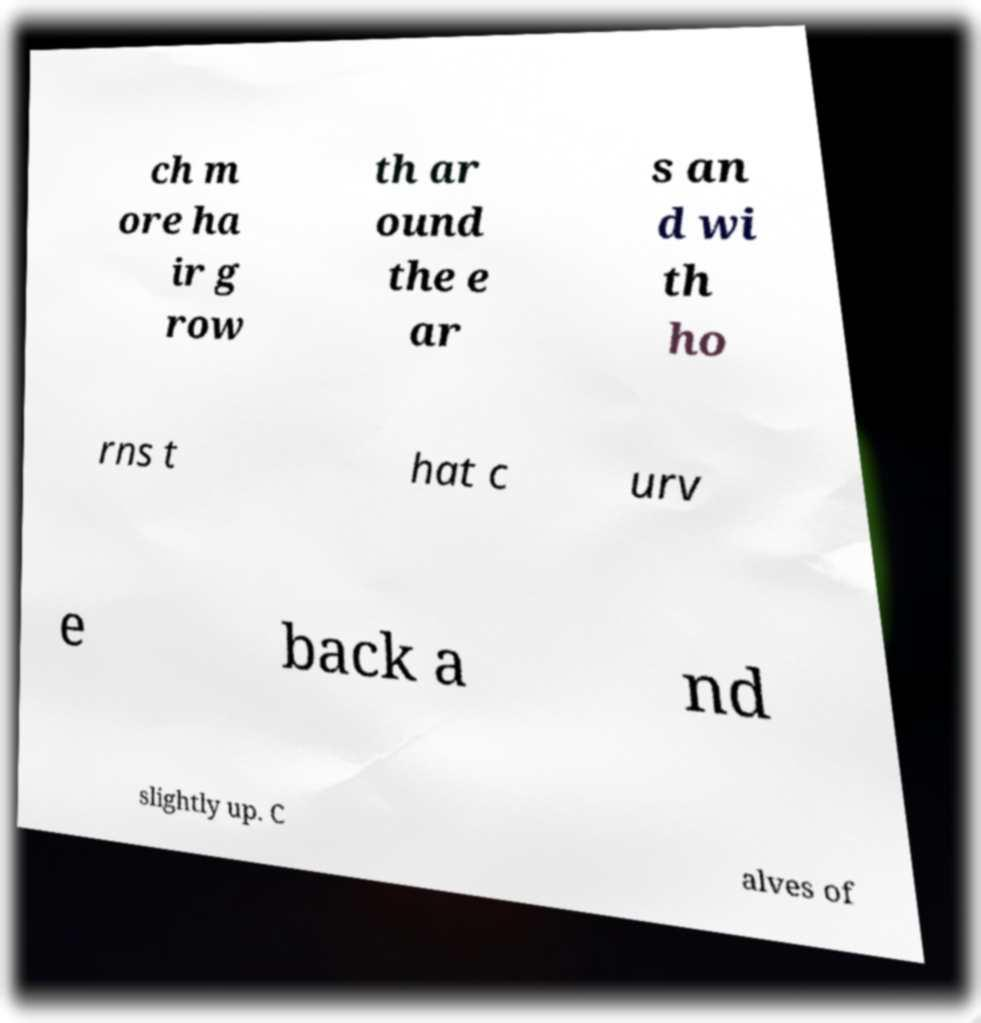Can you read and provide the text displayed in the image?This photo seems to have some interesting text. Can you extract and type it out for me? ch m ore ha ir g row th ar ound the e ar s an d wi th ho rns t hat c urv e back a nd slightly up. C alves of 